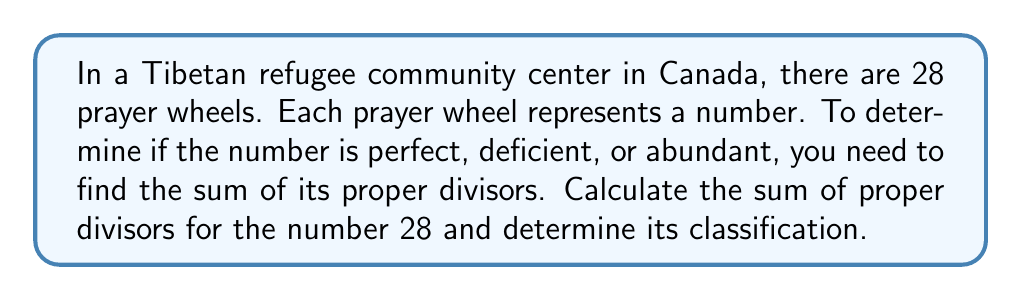Give your solution to this math problem. Let's approach this step-by-step:

1) First, we need to find all the proper divisors of 28. Proper divisors are all positive divisors of a number other than the number itself.

2) The divisors of 28 are: 1, 2, 4, 7, 14, and 28. 

3) The proper divisors are all of these except 28 itself. So, the proper divisors are: 1, 2, 4, 7, and 14.

4) Now, we sum these proper divisors:

   $$ 1 + 2 + 4 + 7 + 14 = 28 $$

5) To classify the number, we compare this sum to the original number:

   - If the sum is equal to the number, it's perfect.
   - If the sum is less than the number, it's deficient.
   - If the sum is greater than the number, it's abundant.

6) In this case, the sum (28) is equal to the original number (28).

Therefore, 28 is a perfect number.
Answer: Perfect number 